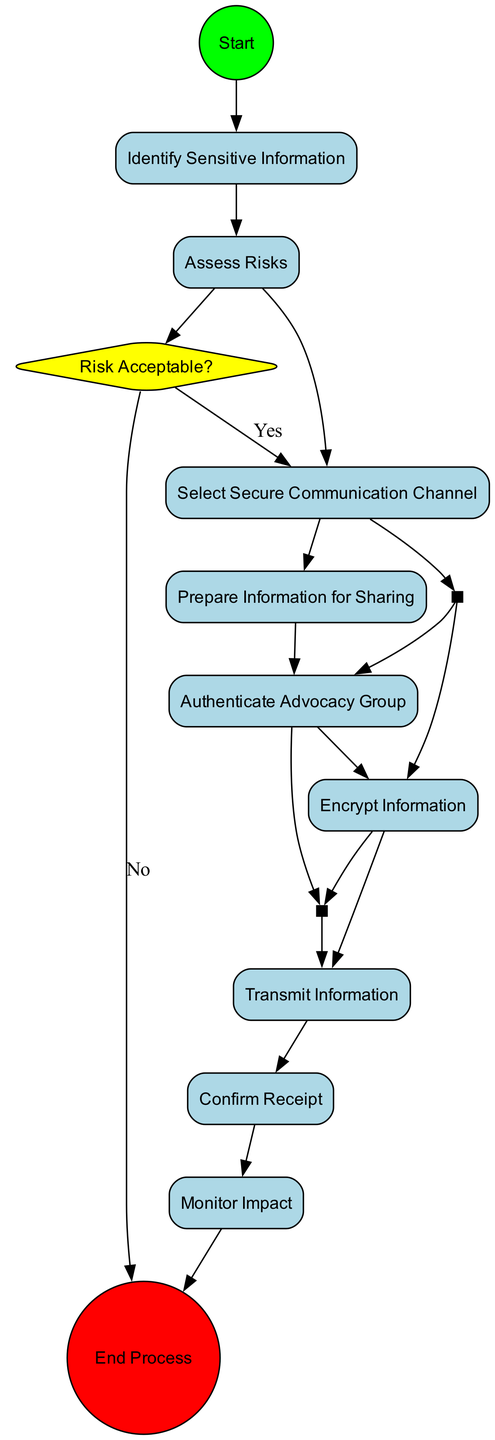What is the first activity in the process? The first node, starting from the 'Start' node, leads to the 'Identify Sensitive Information' activity. This is the initial action in the process flow.
Answer: Identify Sensitive Information How many activities are there in total? By counting each activity node connected sequentially after the 'Start' node, there are nine activities in total, including the final end event.
Answer: Nine Which decision point comes after assessing risks? The diagram indicates that after the 'Assess Risks' activity, there is a diamond-shaped node labeled 'Risk Acceptable?' representing the decision point regarding risk assessment.
Answer: Risk Acceptable? What activities occur in parallel after selecting the secure communication channel? Following the 'Select Secure Communication Channel', there are two activities that start simultaneously: 'Encrypt Information' and 'Authenticate Advocacy Group'. These are the two tasks that branch off from the fork node.
Answer: Encrypt Information and Authenticate Advocacy Group What happens if the risk is deemed unacceptable? If the decision point 'Risk Acceptable?' leads to 'No', then the flow culminates at the end event, indicating the process will not continue with sharing information under those conditions.
Answer: End Process What is the final activity before the end process? The last activity node in the flow, before concluding the process, is 'Confirm Receipt', which indicates that confirmation of information delivery is the last required step before the process ends.
Answer: Confirm Receipt How many edges connect the activities to the end event? Counting from the final activity 'Confirm Receipt' to the end node, there is one direct edge connecting them, illustrating the final step in the process.
Answer: One What is the name of the last decision point in the diagram? The last decision point noted in the flow of the activities is called 'Risk Acceptable?', which addresses the acceptability of risks before proceeding further in the process.
Answer: Risk Acceptable? 